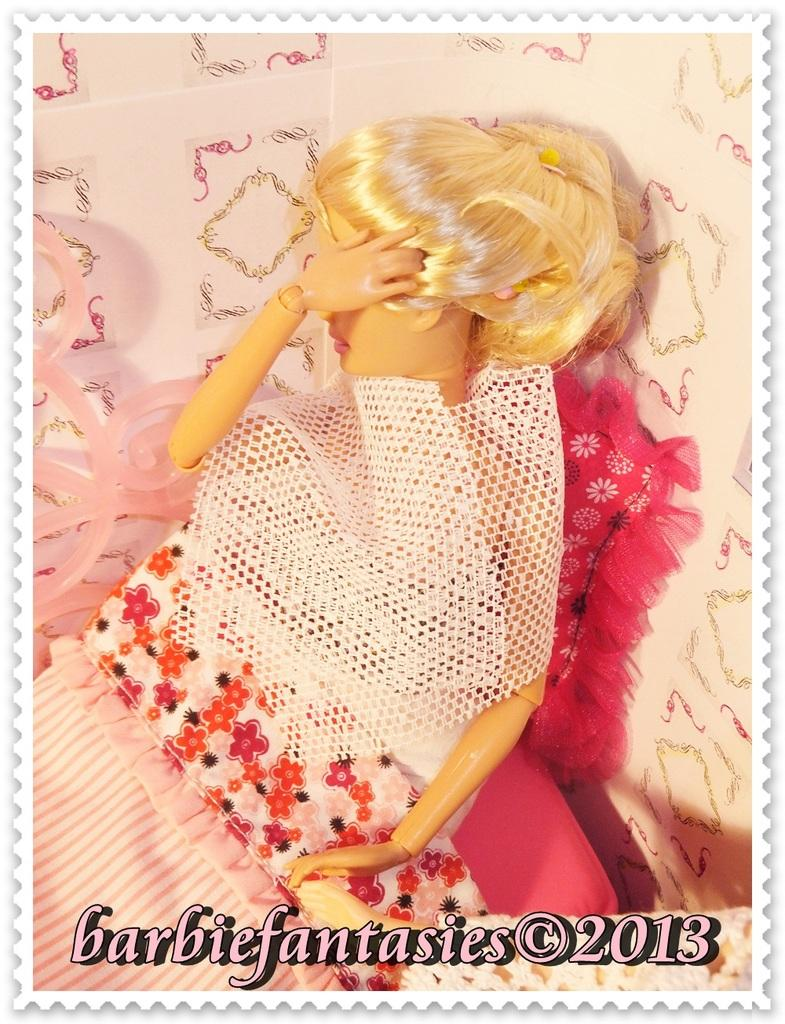What type of doll is in the image? There is a woman's barbie doll in the image. Where is the barbie doll located? The barbie doll is on a bed. What can be seen in the background of the image? There is a wall and a cushion in the background of the image. In which type of setting is the image likely taken? The image is likely taken in a room. What type of needle is being used by the barbie doll in the image? There is no needle present in the image; it features a woman's barbie doll on a bed. How is the cork being utilized by the barbie doll in the image? There is no cork present in the image; it features a woman's barbie doll on a bed. 